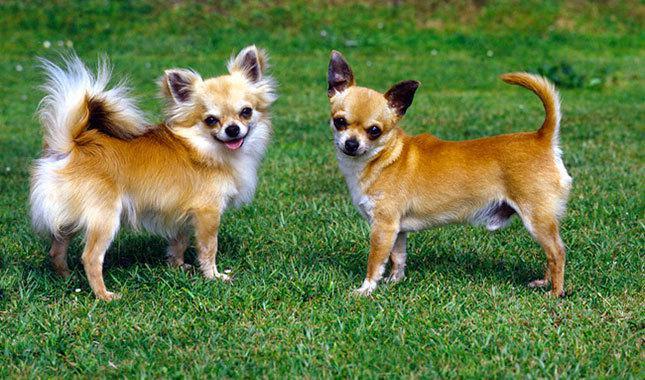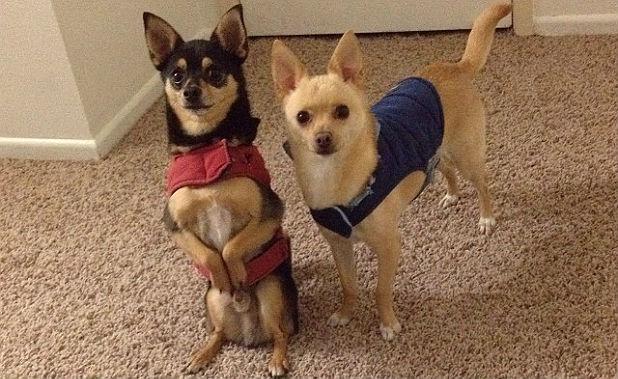The first image is the image on the left, the second image is the image on the right. Given the left and right images, does the statement "Exactly four dogs are shown, two in each image, with two in one image wearing outer wear, each in a different color, even though they are inside." hold true? Answer yes or no. Yes. The first image is the image on the left, the second image is the image on the right. For the images shown, is this caption "Two chihuahuas in different poses are posed together indoors wearing some type of garment." true? Answer yes or no. Yes. 